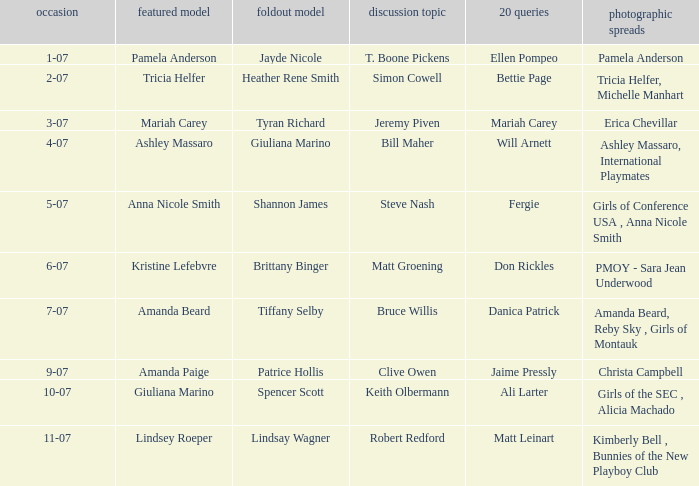Who was the featured model when the edition's photo spreads were pmoy - sara jean underwood? Kristine Lefebvre. 